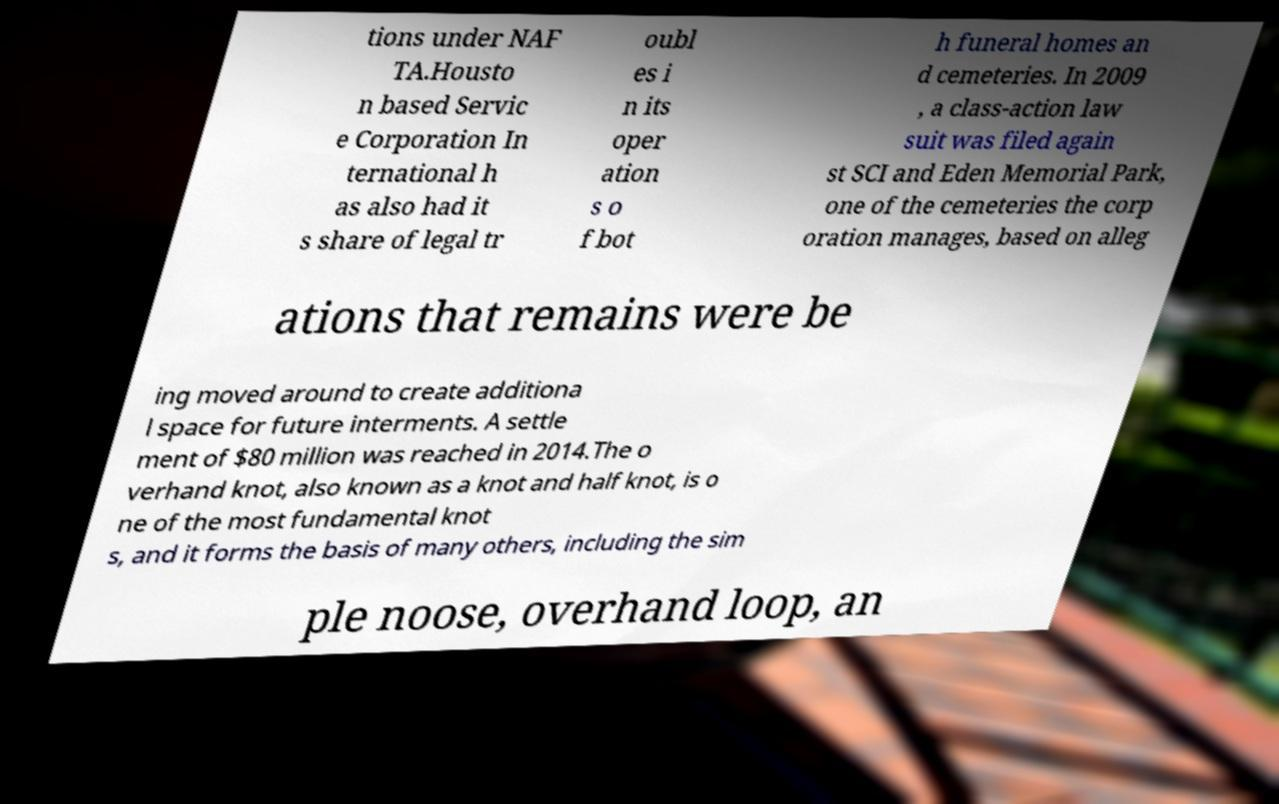For documentation purposes, I need the text within this image transcribed. Could you provide that? tions under NAF TA.Housto n based Servic e Corporation In ternational h as also had it s share of legal tr oubl es i n its oper ation s o f bot h funeral homes an d cemeteries. In 2009 , a class-action law suit was filed again st SCI and Eden Memorial Park, one of the cemeteries the corp oration manages, based on alleg ations that remains were be ing moved around to create additiona l space for future interments. A settle ment of $80 million was reached in 2014.The o verhand knot, also known as a knot and half knot, is o ne of the most fundamental knot s, and it forms the basis of many others, including the sim ple noose, overhand loop, an 